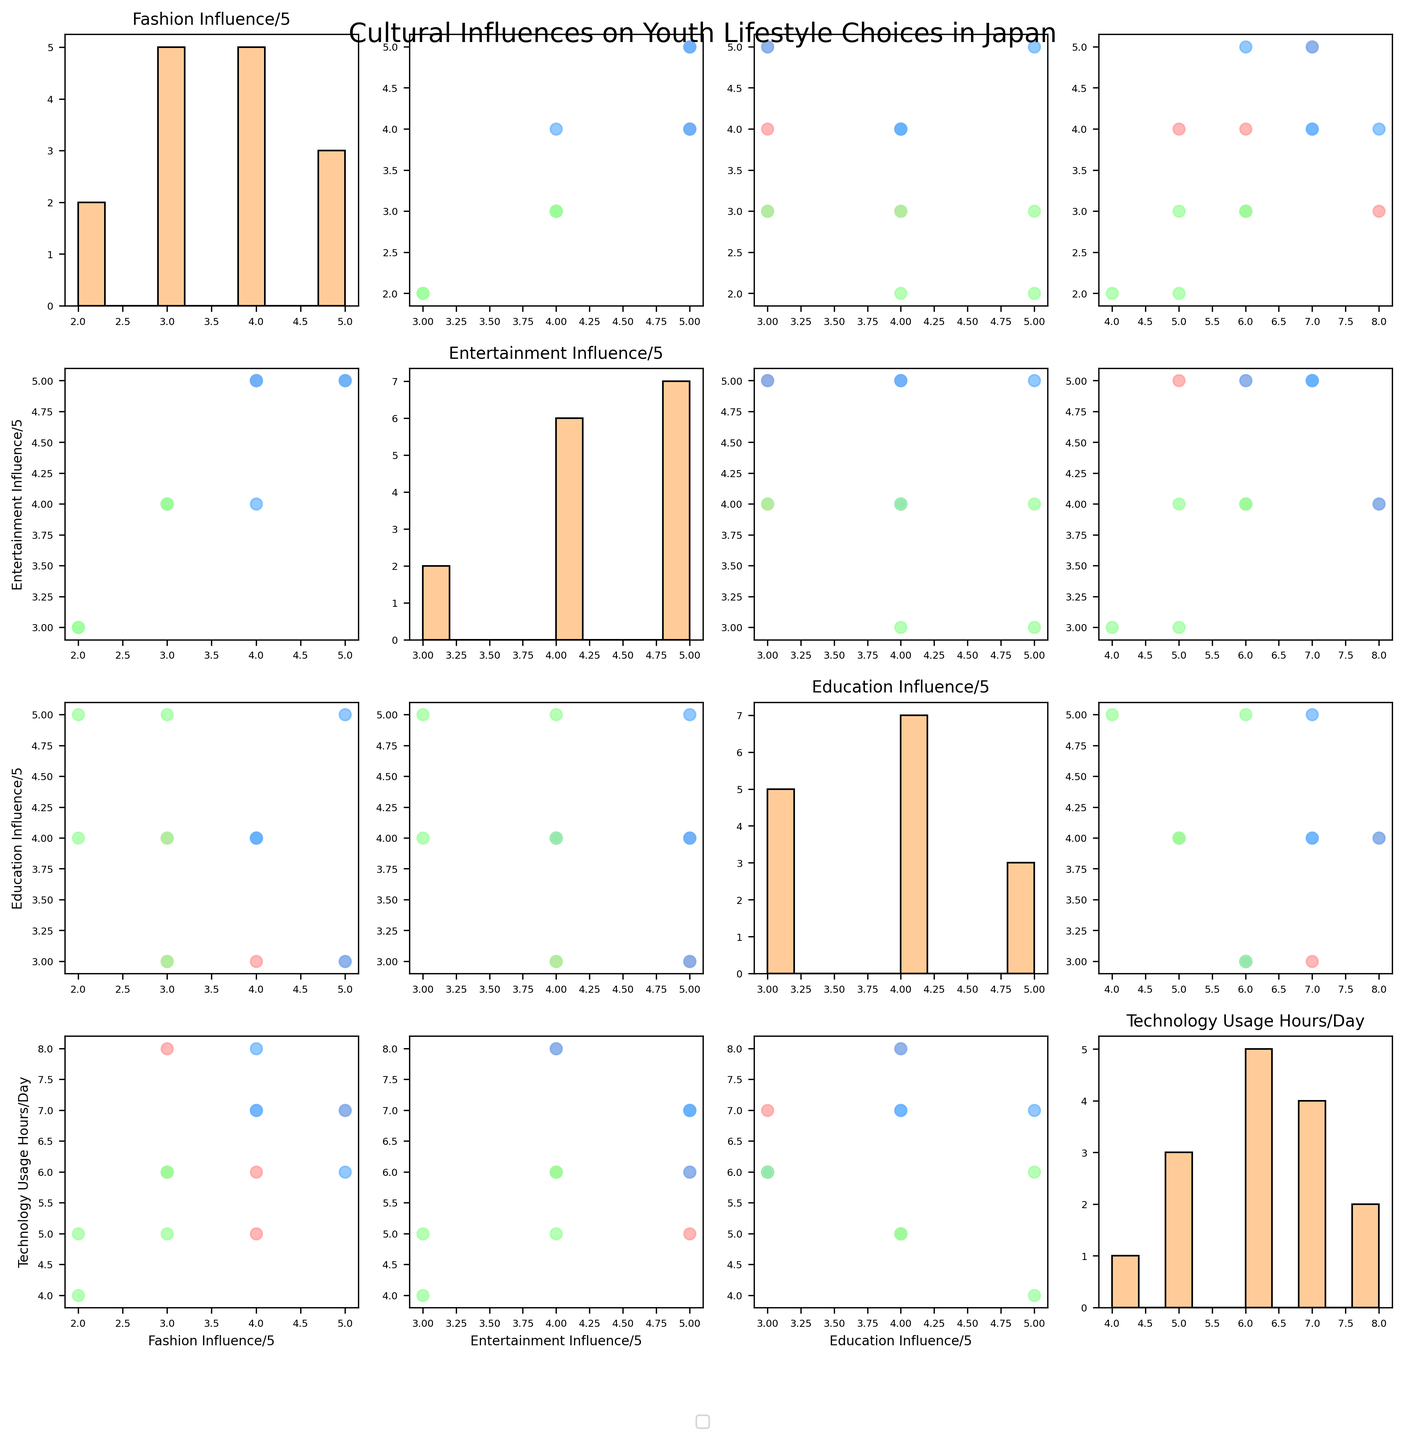What is the title of the figure? The title of the figure is prominently displayed at the top of the chart. It reads, "Cultural Influences on Youth Lifestyle Choices in Japan".
Answer: Cultural Influences on Youth Lifestyle Choices in Japan How many points represent College Students in the scatter plot comparing Education Influence and Technology Usage Hours per Day? In the scatter plot that compares "Education Influence / 5" against "Technology Usage Hours / Day", we look for points labeled "College_Students" with the color blue. We visually count the points.
Answer: 5 Which group has the highest Technology Usage Hours in the scatter plot comparing Fashion Influence and Technology Usage Hours per Day? In the scatter plot of "Fashion Influence / 5" against "Technology Usage Hours / Day", we identify the group associated with the highest value on the Technology Usage Hours axis.
Answer: College_Students What is the trend observed between Fashion Influence and Entertainment Influence? Observing the scatter plot comparing "Fashion Influence / 5" with "Entertainment Influence / 5", we notice that as Fashion Influence increases, Entertainment Influence appears to remain high, especially for Teenagers and College Students categories.
Answer: Positive correlation Which age group shows a wider range of Technology Usage Hours per Day? By comparing the spread of points on the Technology Usage Hours axis across different groups, we check which group has the most spread out points (hence, a wider range).
Answer: Teenagers Between College Students and Young Professionals, which group shows higher Education Influence in the scatter plot comparing Education Influence and Entertainment Influence? In the scatter plot of "Education Influence / 5" vs. "Entertainment Influence / 5", we compare the vertical dispersion of points for College Students (blue) and Young Professionals (green).
Answer: Young Professionals What is the most common Fashion Influence rating among Teenagers? In the histogram for "Fashion Influence / 5", we look for the bar representing Teenagers (using the color legend) with the highest frequency.
Answer: 4 Is Technology Usage Hours related to Entertainment Influence for Young Professionals? Observing the scatter plot comparing "Entertainment Influence / 5" with "Technology Usage Hours / Day" for Young Professionals (green points), we need to assess whether a pattern or trend is visible.
Answer: No clear correlation Which group has more consistent (less variable) Fashion Influence ratings? For each category, we examine the spread of data points in the histograms of "Fashion Influence / 5" to determine which group has the least spread or variability.
Answer: College Students Which group occupies the highest spot in Entertainment Influence categories? In the scatter plot of "Entertainment Influence / 5", we identify which group reaches the highest value in the vertical axis.
Answer: Teenagers 